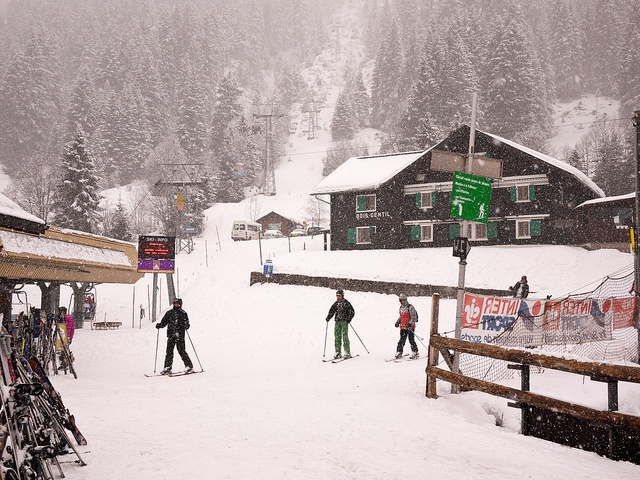Describe the objects in this image and their specific colors. I can see people in darkgray, black, white, and gray tones, people in darkgray, black, gray, and lightgray tones, people in darkgray, black, gray, and brown tones, skis in darkgray, white, gray, and maroon tones, and car in darkgray, lightgray, and gray tones in this image. 